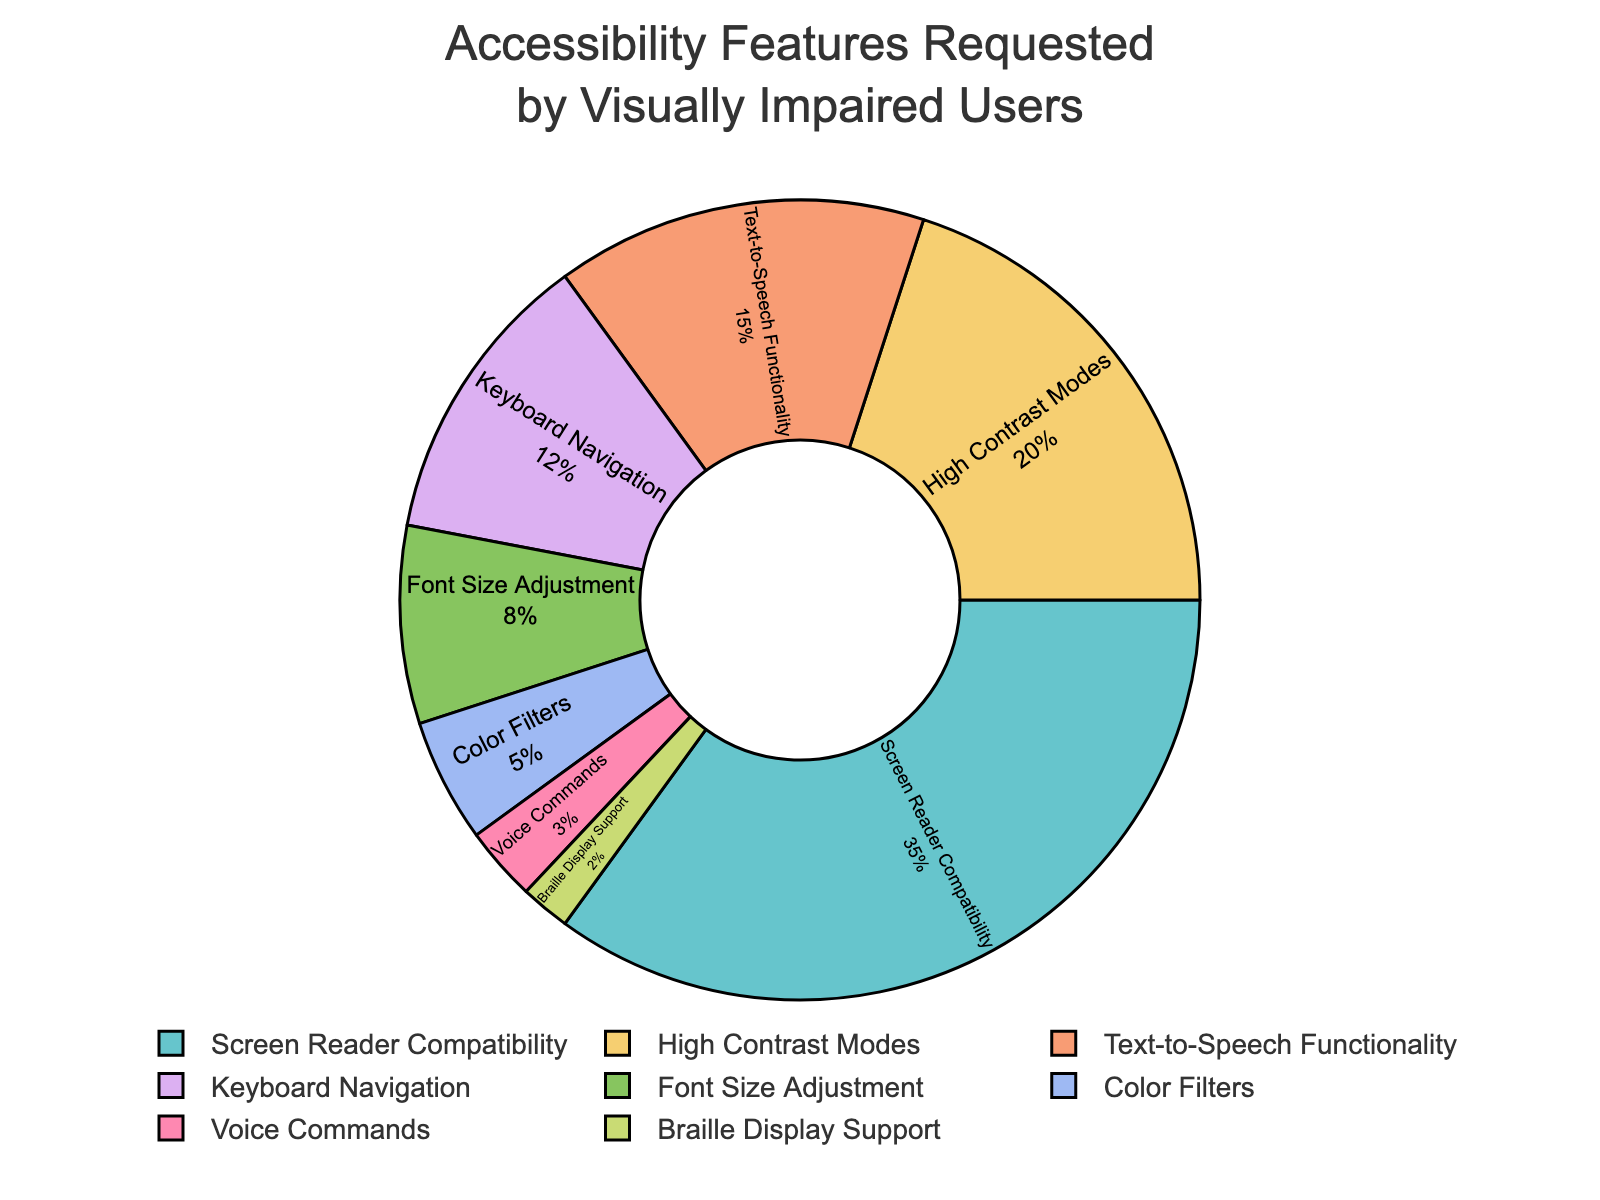What's the most requested accessibility feature among visually impaired users? The pie chart shows "Screen Reader Compatibility" with the largest section, representing 35%.
Answer: Screen Reader Compatibility Which two accessibility features combined make up more than half of the requests? Adding the percentages of the top two features: Screen Reader Compatibility (35%) and High Contrast Modes (20%) results in 35% + 20% = 55%.
Answer: Screen Reader Compatibility and High Contrast Modes What is the percentage difference between the most and the least requested accessibility features? The most requested feature is Screen Reader Compatibility (35%) and the least is Braille Display Support (2%). The difference is 35% - 2% = 33%.
Answer: 33% Is "Text-to-Speech Functionality" more or less requested than "High Contrast Modes"? The pie chart shows "Text-to-Speech Functionality" at 15% and "High Contrast Modes" at 20%. Therefore, "Text-to-Speech Functionality" is less requested.
Answer: Less What percentage of features are requested by 5% or fewer users? The features with 5% or fewer requests are Color Filters (5%), Voice Commands (3%), and Braille Display Support (2%). Summing these gives 5% + 3% + 2% = 10%.
Answer: 10% Which feature has a request percentage nearly equal to 10%? The pie chart shows "Keyboard Navigation" at 12%, which is the closest to 10%.
Answer: Keyboard Navigation How does the request percentage for "Keyboard Navigation" compare to that of "Font Size Adjustment"? "Keyboard Navigation" has 12%, and "Font Size Adjustment" has 8%. Comparing these, 12% is greater than 8%.
Answer: Greater If you were to group the features into those requested by more than 10% and those requested by 10% or fewer users, which features would fall into each group? More than 10%: Screen Reader Compatibility (35%), High Contrast Modes (20%), Text-to-Speech Functionality (15%), and Keyboard Navigation (12%). Ten percent or fewer: Font Size Adjustment (8%), Color Filters (5%), Voice Commands (3%), and Braille Display Support (2%).
Answer: More than 10%: Screen Reader Compatibility, High Contrast Modes, Text-to-Speech Functionality, Keyboard Navigation; 10% or fewer: Font Size Adjustment, Color Filters, Voice Commands, Braille Display Support 